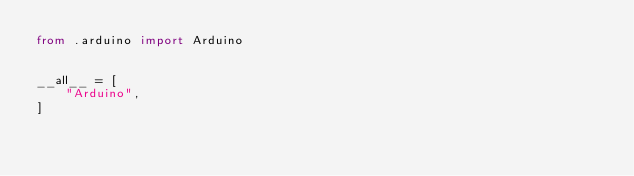<code> <loc_0><loc_0><loc_500><loc_500><_Python_>from .arduino import Arduino


__all__ = [
    "Arduino",
]
</code> 